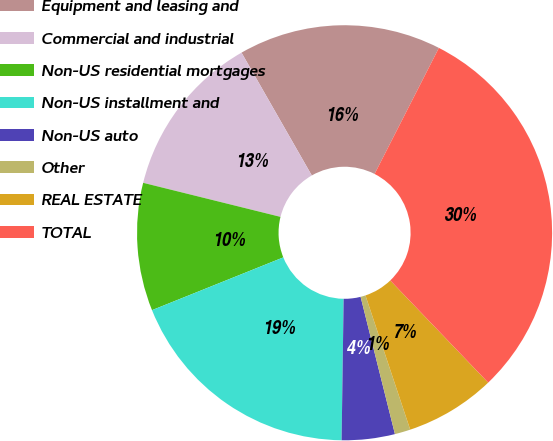Convert chart. <chart><loc_0><loc_0><loc_500><loc_500><pie_chart><fcel>Equipment and leasing and<fcel>Commercial and industrial<fcel>Non-US residential mortgages<fcel>Non-US installment and<fcel>Non-US auto<fcel>Other<fcel>REAL ESTATE<fcel>TOTAL<nl><fcel>15.78%<fcel>12.86%<fcel>9.95%<fcel>18.69%<fcel>4.13%<fcel>1.22%<fcel>7.04%<fcel>30.33%<nl></chart> 